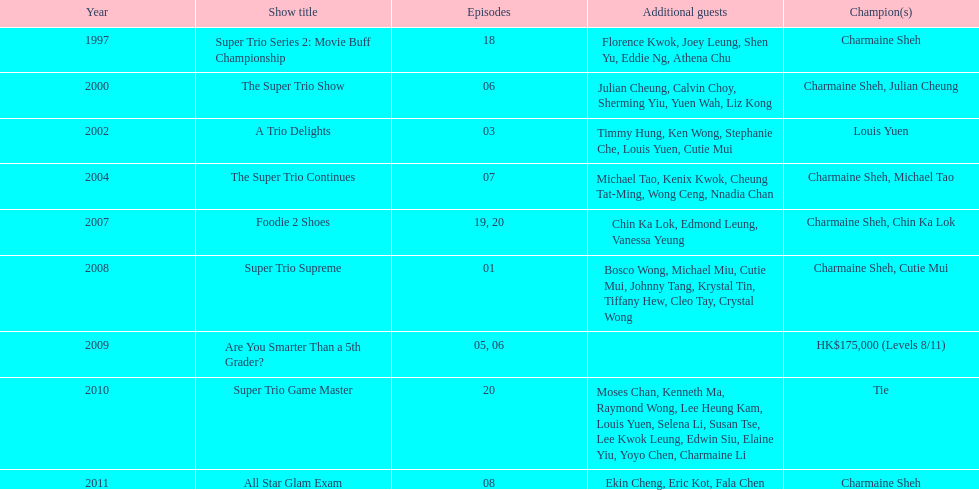What is the number of other guests in the 2002 show "a trio delights"? 5. 